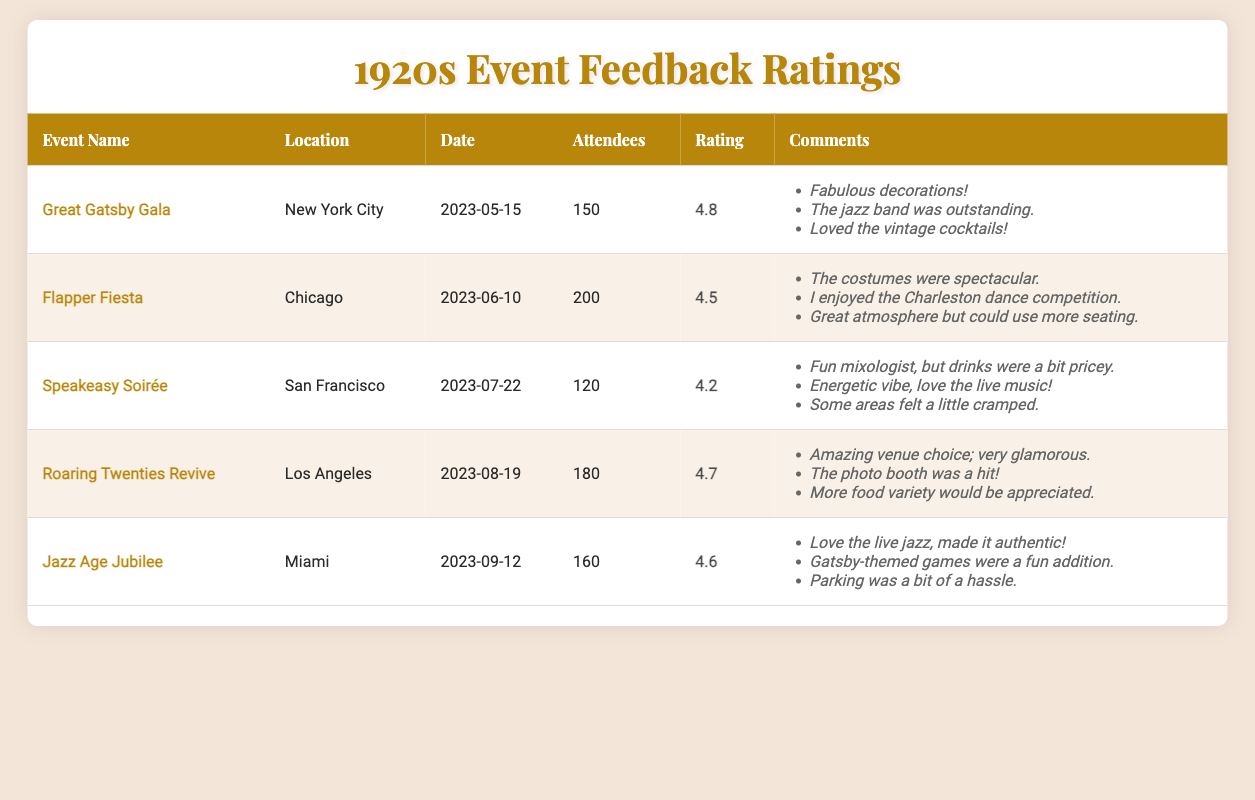What was the highest overall rating among the events? Looking through the overall ratings, the "Great Gatsby Gala" has the highest rating of 4.8 compared to the other events listed.
Answer: 4.8 What is the total number of attendees across all events? Adding the total attendees: 150 (Great Gatsby Gala) + 200 (Flapper Fiesta) + 120 (Speakeasy Soirée) + 180 (Roaring Twenties Revive) + 160 (Jazz Age Jubilee) = 910.
Answer: 910 Did the "Flapper Fiesta" receive a rating of 4.5 or higher? The rating for the "Flapper Fiesta" event is 4.5, which meets the requirement of being equal to or higher than 4.5.
Answer: Yes Which event had the lowest number of attendees? Scanning through the attendee counts, the "Speakeasy Soirée" had the lowest number of attendees at 120.
Answer: 120 What is the average rating of all events? To find the average rating, sum the ratings: 4.8 + 4.5 + 4.2 + 4.7 + 4.6 = 22.8. There are 5 events, so divide 22.8 by 5, which equals 4.56.
Answer: 4.56 Which city hosted the event with the lowest overall rating? The event with the lowest overall rating is the "Speakeasy Soirée" with a rating of 4.2, and it was hosted in San Francisco.
Answer: San Francisco Was there any event that received a rating of 4.6 or higher and had more than 150 attendees? The "Great Gatsby Gala" (4.8, 150 attendees), "Roaring Twenties Revive" (4.7, 180 attendees), and "Jazz Age Jubilee" (4.6, 160 attendees) all meet both criteria.
Answer: Yes How many events had a rating above 4.5? The events that had a rating above 4.5 are "Great Gatsby Gala" (4.8), "Flapper Fiesta" (4.5), "Roaring Twenties Revive" (4.7), and "Jazz Age Jubilee" (4.6). This totals four events above 4.5.
Answer: 4 What was the most common comment theme across the events? Themes in comments include decorations, atmosphere, and music. However, comments about decorations and atmosphere were mentioned in most events, suggesting these are common areas of feedback.
Answer: Decorations and atmosphere 